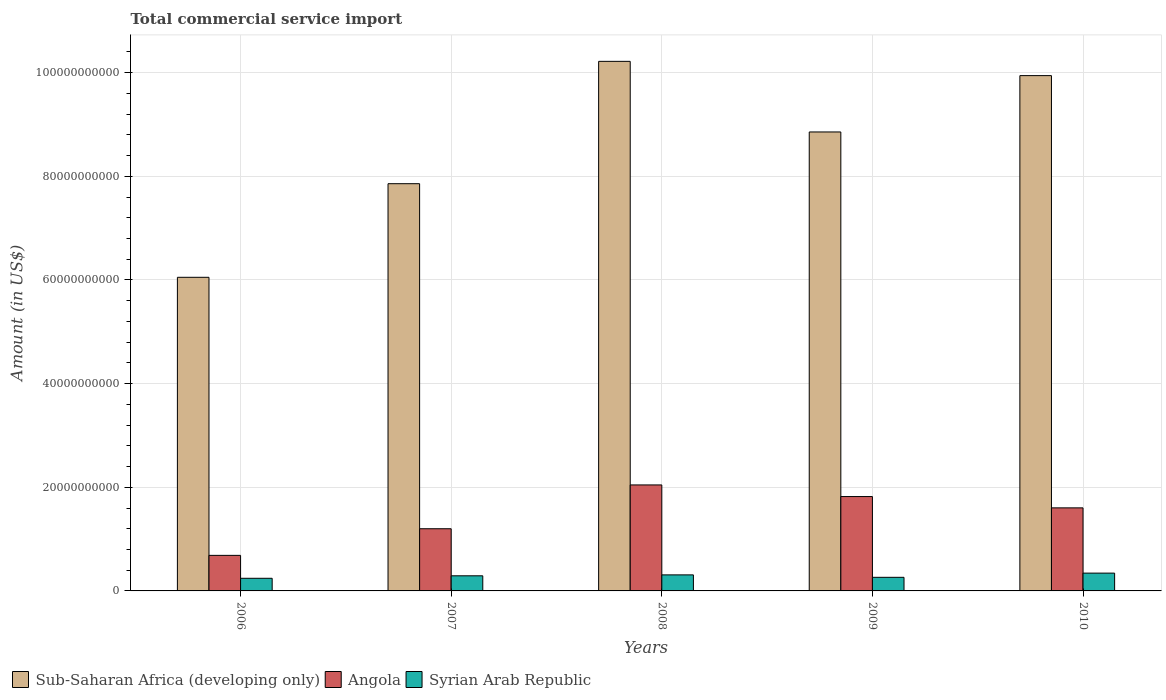How many different coloured bars are there?
Give a very brief answer. 3. Are the number of bars per tick equal to the number of legend labels?
Provide a succinct answer. Yes. Are the number of bars on each tick of the X-axis equal?
Give a very brief answer. Yes. How many bars are there on the 2nd tick from the left?
Your answer should be compact. 3. What is the label of the 3rd group of bars from the left?
Provide a short and direct response. 2008. What is the total commercial service import in Angola in 2007?
Give a very brief answer. 1.20e+1. Across all years, what is the maximum total commercial service import in Syrian Arab Republic?
Keep it short and to the point. 3.44e+09. Across all years, what is the minimum total commercial service import in Angola?
Offer a very short reply. 6.86e+09. What is the total total commercial service import in Angola in the graph?
Provide a short and direct response. 7.35e+1. What is the difference between the total commercial service import in Syrian Arab Republic in 2008 and that in 2010?
Provide a succinct answer. -3.41e+08. What is the difference between the total commercial service import in Syrian Arab Republic in 2009 and the total commercial service import in Angola in 2006?
Your response must be concise. -4.24e+09. What is the average total commercial service import in Angola per year?
Make the answer very short. 1.47e+1. In the year 2010, what is the difference between the total commercial service import in Sub-Saharan Africa (developing only) and total commercial service import in Syrian Arab Republic?
Your answer should be compact. 9.60e+1. In how many years, is the total commercial service import in Sub-Saharan Africa (developing only) greater than 96000000000 US$?
Offer a very short reply. 2. What is the ratio of the total commercial service import in Syrian Arab Republic in 2006 to that in 2007?
Keep it short and to the point. 0.84. Is the total commercial service import in Angola in 2006 less than that in 2008?
Give a very brief answer. Yes. What is the difference between the highest and the second highest total commercial service import in Syrian Arab Republic?
Give a very brief answer. 3.41e+08. What is the difference between the highest and the lowest total commercial service import in Sub-Saharan Africa (developing only)?
Your response must be concise. 4.17e+1. Is the sum of the total commercial service import in Sub-Saharan Africa (developing only) in 2006 and 2009 greater than the maximum total commercial service import in Syrian Arab Republic across all years?
Provide a short and direct response. Yes. What does the 2nd bar from the left in 2007 represents?
Your answer should be very brief. Angola. What does the 2nd bar from the right in 2010 represents?
Ensure brevity in your answer.  Angola. How many bars are there?
Provide a short and direct response. 15. What is the difference between two consecutive major ticks on the Y-axis?
Offer a terse response. 2.00e+1. Are the values on the major ticks of Y-axis written in scientific E-notation?
Provide a short and direct response. No. Does the graph contain any zero values?
Your answer should be very brief. No. Does the graph contain grids?
Give a very brief answer. Yes. Where does the legend appear in the graph?
Provide a succinct answer. Bottom left. What is the title of the graph?
Offer a terse response. Total commercial service import. What is the label or title of the X-axis?
Your answer should be very brief. Years. What is the label or title of the Y-axis?
Your answer should be very brief. Amount (in US$). What is the Amount (in US$) in Sub-Saharan Africa (developing only) in 2006?
Give a very brief answer. 6.05e+1. What is the Amount (in US$) of Angola in 2006?
Your answer should be compact. 6.86e+09. What is the Amount (in US$) in Syrian Arab Republic in 2006?
Offer a terse response. 2.44e+09. What is the Amount (in US$) of Sub-Saharan Africa (developing only) in 2007?
Provide a short and direct response. 7.86e+1. What is the Amount (in US$) in Angola in 2007?
Ensure brevity in your answer.  1.20e+1. What is the Amount (in US$) in Syrian Arab Republic in 2007?
Your response must be concise. 2.92e+09. What is the Amount (in US$) in Sub-Saharan Africa (developing only) in 2008?
Make the answer very short. 1.02e+11. What is the Amount (in US$) of Angola in 2008?
Provide a short and direct response. 2.05e+1. What is the Amount (in US$) of Syrian Arab Republic in 2008?
Ensure brevity in your answer.  3.10e+09. What is the Amount (in US$) of Sub-Saharan Africa (developing only) in 2009?
Provide a short and direct response. 8.86e+1. What is the Amount (in US$) in Angola in 2009?
Offer a terse response. 1.82e+1. What is the Amount (in US$) of Syrian Arab Republic in 2009?
Give a very brief answer. 2.62e+09. What is the Amount (in US$) of Sub-Saharan Africa (developing only) in 2010?
Provide a short and direct response. 9.94e+1. What is the Amount (in US$) of Angola in 2010?
Give a very brief answer. 1.60e+1. What is the Amount (in US$) in Syrian Arab Republic in 2010?
Offer a very short reply. 3.44e+09. Across all years, what is the maximum Amount (in US$) of Sub-Saharan Africa (developing only)?
Provide a short and direct response. 1.02e+11. Across all years, what is the maximum Amount (in US$) in Angola?
Ensure brevity in your answer.  2.05e+1. Across all years, what is the maximum Amount (in US$) of Syrian Arab Republic?
Provide a succinct answer. 3.44e+09. Across all years, what is the minimum Amount (in US$) of Sub-Saharan Africa (developing only)?
Keep it short and to the point. 6.05e+1. Across all years, what is the minimum Amount (in US$) of Angola?
Your answer should be compact. 6.86e+09. Across all years, what is the minimum Amount (in US$) of Syrian Arab Republic?
Offer a terse response. 2.44e+09. What is the total Amount (in US$) of Sub-Saharan Africa (developing only) in the graph?
Make the answer very short. 4.29e+11. What is the total Amount (in US$) in Angola in the graph?
Ensure brevity in your answer.  7.35e+1. What is the total Amount (in US$) of Syrian Arab Republic in the graph?
Make the answer very short. 1.45e+1. What is the difference between the Amount (in US$) of Sub-Saharan Africa (developing only) in 2006 and that in 2007?
Give a very brief answer. -1.81e+1. What is the difference between the Amount (in US$) in Angola in 2006 and that in 2007?
Provide a short and direct response. -5.14e+09. What is the difference between the Amount (in US$) of Syrian Arab Republic in 2006 and that in 2007?
Offer a terse response. -4.80e+08. What is the difference between the Amount (in US$) of Sub-Saharan Africa (developing only) in 2006 and that in 2008?
Provide a short and direct response. -4.17e+1. What is the difference between the Amount (in US$) of Angola in 2006 and that in 2008?
Your answer should be very brief. -1.36e+1. What is the difference between the Amount (in US$) in Syrian Arab Republic in 2006 and that in 2008?
Make the answer very short. -6.59e+08. What is the difference between the Amount (in US$) of Sub-Saharan Africa (developing only) in 2006 and that in 2009?
Your answer should be very brief. -2.80e+1. What is the difference between the Amount (in US$) of Angola in 2006 and that in 2009?
Give a very brief answer. -1.14e+1. What is the difference between the Amount (in US$) in Syrian Arab Republic in 2006 and that in 2009?
Offer a very short reply. -1.86e+08. What is the difference between the Amount (in US$) of Sub-Saharan Africa (developing only) in 2006 and that in 2010?
Offer a very short reply. -3.89e+1. What is the difference between the Amount (in US$) of Angola in 2006 and that in 2010?
Your response must be concise. -9.17e+09. What is the difference between the Amount (in US$) of Syrian Arab Republic in 2006 and that in 2010?
Provide a succinct answer. -1.00e+09. What is the difference between the Amount (in US$) in Sub-Saharan Africa (developing only) in 2007 and that in 2008?
Make the answer very short. -2.36e+1. What is the difference between the Amount (in US$) in Angola in 2007 and that in 2008?
Your answer should be compact. -8.45e+09. What is the difference between the Amount (in US$) of Syrian Arab Republic in 2007 and that in 2008?
Your answer should be compact. -1.80e+08. What is the difference between the Amount (in US$) in Sub-Saharan Africa (developing only) in 2007 and that in 2009?
Your response must be concise. -9.98e+09. What is the difference between the Amount (in US$) of Angola in 2007 and that in 2009?
Provide a succinct answer. -6.21e+09. What is the difference between the Amount (in US$) of Syrian Arab Republic in 2007 and that in 2009?
Give a very brief answer. 2.93e+08. What is the difference between the Amount (in US$) of Sub-Saharan Africa (developing only) in 2007 and that in 2010?
Keep it short and to the point. -2.09e+1. What is the difference between the Amount (in US$) of Angola in 2007 and that in 2010?
Offer a very short reply. -4.03e+09. What is the difference between the Amount (in US$) in Syrian Arab Republic in 2007 and that in 2010?
Your response must be concise. -5.20e+08. What is the difference between the Amount (in US$) of Sub-Saharan Africa (developing only) in 2008 and that in 2009?
Offer a very short reply. 1.36e+1. What is the difference between the Amount (in US$) in Angola in 2008 and that in 2009?
Your answer should be compact. 2.24e+09. What is the difference between the Amount (in US$) of Syrian Arab Republic in 2008 and that in 2009?
Give a very brief answer. 4.73e+08. What is the difference between the Amount (in US$) of Sub-Saharan Africa (developing only) in 2008 and that in 2010?
Your response must be concise. 2.75e+09. What is the difference between the Amount (in US$) of Angola in 2008 and that in 2010?
Provide a short and direct response. 4.42e+09. What is the difference between the Amount (in US$) in Syrian Arab Republic in 2008 and that in 2010?
Your response must be concise. -3.41e+08. What is the difference between the Amount (in US$) of Sub-Saharan Africa (developing only) in 2009 and that in 2010?
Give a very brief answer. -1.09e+1. What is the difference between the Amount (in US$) of Angola in 2009 and that in 2010?
Your response must be concise. 2.18e+09. What is the difference between the Amount (in US$) in Syrian Arab Republic in 2009 and that in 2010?
Your response must be concise. -8.14e+08. What is the difference between the Amount (in US$) of Sub-Saharan Africa (developing only) in 2006 and the Amount (in US$) of Angola in 2007?
Ensure brevity in your answer.  4.85e+1. What is the difference between the Amount (in US$) of Sub-Saharan Africa (developing only) in 2006 and the Amount (in US$) of Syrian Arab Republic in 2007?
Offer a very short reply. 5.76e+1. What is the difference between the Amount (in US$) of Angola in 2006 and the Amount (in US$) of Syrian Arab Republic in 2007?
Your response must be concise. 3.94e+09. What is the difference between the Amount (in US$) in Sub-Saharan Africa (developing only) in 2006 and the Amount (in US$) in Angola in 2008?
Offer a terse response. 4.01e+1. What is the difference between the Amount (in US$) in Sub-Saharan Africa (developing only) in 2006 and the Amount (in US$) in Syrian Arab Republic in 2008?
Make the answer very short. 5.74e+1. What is the difference between the Amount (in US$) in Angola in 2006 and the Amount (in US$) in Syrian Arab Republic in 2008?
Keep it short and to the point. 3.76e+09. What is the difference between the Amount (in US$) of Sub-Saharan Africa (developing only) in 2006 and the Amount (in US$) of Angola in 2009?
Give a very brief answer. 4.23e+1. What is the difference between the Amount (in US$) of Sub-Saharan Africa (developing only) in 2006 and the Amount (in US$) of Syrian Arab Republic in 2009?
Offer a very short reply. 5.79e+1. What is the difference between the Amount (in US$) of Angola in 2006 and the Amount (in US$) of Syrian Arab Republic in 2009?
Ensure brevity in your answer.  4.24e+09. What is the difference between the Amount (in US$) in Sub-Saharan Africa (developing only) in 2006 and the Amount (in US$) in Angola in 2010?
Ensure brevity in your answer.  4.45e+1. What is the difference between the Amount (in US$) of Sub-Saharan Africa (developing only) in 2006 and the Amount (in US$) of Syrian Arab Republic in 2010?
Keep it short and to the point. 5.71e+1. What is the difference between the Amount (in US$) of Angola in 2006 and the Amount (in US$) of Syrian Arab Republic in 2010?
Make the answer very short. 3.42e+09. What is the difference between the Amount (in US$) in Sub-Saharan Africa (developing only) in 2007 and the Amount (in US$) in Angola in 2008?
Provide a succinct answer. 5.81e+1. What is the difference between the Amount (in US$) of Sub-Saharan Africa (developing only) in 2007 and the Amount (in US$) of Syrian Arab Republic in 2008?
Give a very brief answer. 7.55e+1. What is the difference between the Amount (in US$) in Angola in 2007 and the Amount (in US$) in Syrian Arab Republic in 2008?
Offer a very short reply. 8.90e+09. What is the difference between the Amount (in US$) of Sub-Saharan Africa (developing only) in 2007 and the Amount (in US$) of Angola in 2009?
Offer a very short reply. 6.04e+1. What is the difference between the Amount (in US$) of Sub-Saharan Africa (developing only) in 2007 and the Amount (in US$) of Syrian Arab Republic in 2009?
Make the answer very short. 7.60e+1. What is the difference between the Amount (in US$) of Angola in 2007 and the Amount (in US$) of Syrian Arab Republic in 2009?
Offer a terse response. 9.37e+09. What is the difference between the Amount (in US$) in Sub-Saharan Africa (developing only) in 2007 and the Amount (in US$) in Angola in 2010?
Your answer should be very brief. 6.26e+1. What is the difference between the Amount (in US$) in Sub-Saharan Africa (developing only) in 2007 and the Amount (in US$) in Syrian Arab Republic in 2010?
Offer a terse response. 7.51e+1. What is the difference between the Amount (in US$) of Angola in 2007 and the Amount (in US$) of Syrian Arab Republic in 2010?
Give a very brief answer. 8.56e+09. What is the difference between the Amount (in US$) of Sub-Saharan Africa (developing only) in 2008 and the Amount (in US$) of Angola in 2009?
Offer a terse response. 8.40e+1. What is the difference between the Amount (in US$) of Sub-Saharan Africa (developing only) in 2008 and the Amount (in US$) of Syrian Arab Republic in 2009?
Provide a succinct answer. 9.96e+1. What is the difference between the Amount (in US$) in Angola in 2008 and the Amount (in US$) in Syrian Arab Republic in 2009?
Keep it short and to the point. 1.78e+1. What is the difference between the Amount (in US$) in Sub-Saharan Africa (developing only) in 2008 and the Amount (in US$) in Angola in 2010?
Give a very brief answer. 8.62e+1. What is the difference between the Amount (in US$) in Sub-Saharan Africa (developing only) in 2008 and the Amount (in US$) in Syrian Arab Republic in 2010?
Provide a short and direct response. 9.88e+1. What is the difference between the Amount (in US$) of Angola in 2008 and the Amount (in US$) of Syrian Arab Republic in 2010?
Your response must be concise. 1.70e+1. What is the difference between the Amount (in US$) in Sub-Saharan Africa (developing only) in 2009 and the Amount (in US$) in Angola in 2010?
Offer a very short reply. 7.25e+1. What is the difference between the Amount (in US$) in Sub-Saharan Africa (developing only) in 2009 and the Amount (in US$) in Syrian Arab Republic in 2010?
Your response must be concise. 8.51e+1. What is the difference between the Amount (in US$) of Angola in 2009 and the Amount (in US$) of Syrian Arab Republic in 2010?
Keep it short and to the point. 1.48e+1. What is the average Amount (in US$) in Sub-Saharan Africa (developing only) per year?
Provide a short and direct response. 8.59e+1. What is the average Amount (in US$) of Angola per year?
Your answer should be very brief. 1.47e+1. What is the average Amount (in US$) of Syrian Arab Republic per year?
Your answer should be very brief. 2.90e+09. In the year 2006, what is the difference between the Amount (in US$) of Sub-Saharan Africa (developing only) and Amount (in US$) of Angola?
Offer a very short reply. 5.37e+1. In the year 2006, what is the difference between the Amount (in US$) in Sub-Saharan Africa (developing only) and Amount (in US$) in Syrian Arab Republic?
Ensure brevity in your answer.  5.81e+1. In the year 2006, what is the difference between the Amount (in US$) in Angola and Amount (in US$) in Syrian Arab Republic?
Provide a succinct answer. 4.42e+09. In the year 2007, what is the difference between the Amount (in US$) in Sub-Saharan Africa (developing only) and Amount (in US$) in Angola?
Ensure brevity in your answer.  6.66e+1. In the year 2007, what is the difference between the Amount (in US$) in Sub-Saharan Africa (developing only) and Amount (in US$) in Syrian Arab Republic?
Offer a terse response. 7.57e+1. In the year 2007, what is the difference between the Amount (in US$) in Angola and Amount (in US$) in Syrian Arab Republic?
Provide a short and direct response. 9.08e+09. In the year 2008, what is the difference between the Amount (in US$) in Sub-Saharan Africa (developing only) and Amount (in US$) in Angola?
Ensure brevity in your answer.  8.17e+1. In the year 2008, what is the difference between the Amount (in US$) of Sub-Saharan Africa (developing only) and Amount (in US$) of Syrian Arab Republic?
Offer a terse response. 9.91e+1. In the year 2008, what is the difference between the Amount (in US$) of Angola and Amount (in US$) of Syrian Arab Republic?
Make the answer very short. 1.74e+1. In the year 2009, what is the difference between the Amount (in US$) of Sub-Saharan Africa (developing only) and Amount (in US$) of Angola?
Your answer should be compact. 7.04e+1. In the year 2009, what is the difference between the Amount (in US$) in Sub-Saharan Africa (developing only) and Amount (in US$) in Syrian Arab Republic?
Your response must be concise. 8.59e+1. In the year 2009, what is the difference between the Amount (in US$) of Angola and Amount (in US$) of Syrian Arab Republic?
Your answer should be very brief. 1.56e+1. In the year 2010, what is the difference between the Amount (in US$) in Sub-Saharan Africa (developing only) and Amount (in US$) in Angola?
Make the answer very short. 8.34e+1. In the year 2010, what is the difference between the Amount (in US$) in Sub-Saharan Africa (developing only) and Amount (in US$) in Syrian Arab Republic?
Give a very brief answer. 9.60e+1. In the year 2010, what is the difference between the Amount (in US$) of Angola and Amount (in US$) of Syrian Arab Republic?
Give a very brief answer. 1.26e+1. What is the ratio of the Amount (in US$) in Sub-Saharan Africa (developing only) in 2006 to that in 2007?
Offer a very short reply. 0.77. What is the ratio of the Amount (in US$) in Angola in 2006 to that in 2007?
Your answer should be compact. 0.57. What is the ratio of the Amount (in US$) in Syrian Arab Republic in 2006 to that in 2007?
Keep it short and to the point. 0.84. What is the ratio of the Amount (in US$) of Sub-Saharan Africa (developing only) in 2006 to that in 2008?
Offer a terse response. 0.59. What is the ratio of the Amount (in US$) in Angola in 2006 to that in 2008?
Your answer should be very brief. 0.34. What is the ratio of the Amount (in US$) of Syrian Arab Republic in 2006 to that in 2008?
Your response must be concise. 0.79. What is the ratio of the Amount (in US$) of Sub-Saharan Africa (developing only) in 2006 to that in 2009?
Offer a very short reply. 0.68. What is the ratio of the Amount (in US$) of Angola in 2006 to that in 2009?
Ensure brevity in your answer.  0.38. What is the ratio of the Amount (in US$) in Syrian Arab Republic in 2006 to that in 2009?
Your response must be concise. 0.93. What is the ratio of the Amount (in US$) of Sub-Saharan Africa (developing only) in 2006 to that in 2010?
Offer a terse response. 0.61. What is the ratio of the Amount (in US$) in Angola in 2006 to that in 2010?
Provide a succinct answer. 0.43. What is the ratio of the Amount (in US$) in Syrian Arab Republic in 2006 to that in 2010?
Your answer should be compact. 0.71. What is the ratio of the Amount (in US$) of Sub-Saharan Africa (developing only) in 2007 to that in 2008?
Ensure brevity in your answer.  0.77. What is the ratio of the Amount (in US$) in Angola in 2007 to that in 2008?
Give a very brief answer. 0.59. What is the ratio of the Amount (in US$) of Syrian Arab Republic in 2007 to that in 2008?
Provide a succinct answer. 0.94. What is the ratio of the Amount (in US$) of Sub-Saharan Africa (developing only) in 2007 to that in 2009?
Provide a succinct answer. 0.89. What is the ratio of the Amount (in US$) of Angola in 2007 to that in 2009?
Offer a terse response. 0.66. What is the ratio of the Amount (in US$) in Syrian Arab Republic in 2007 to that in 2009?
Provide a short and direct response. 1.11. What is the ratio of the Amount (in US$) in Sub-Saharan Africa (developing only) in 2007 to that in 2010?
Your response must be concise. 0.79. What is the ratio of the Amount (in US$) in Angola in 2007 to that in 2010?
Ensure brevity in your answer.  0.75. What is the ratio of the Amount (in US$) in Syrian Arab Republic in 2007 to that in 2010?
Give a very brief answer. 0.85. What is the ratio of the Amount (in US$) in Sub-Saharan Africa (developing only) in 2008 to that in 2009?
Your response must be concise. 1.15. What is the ratio of the Amount (in US$) of Angola in 2008 to that in 2009?
Your answer should be very brief. 1.12. What is the ratio of the Amount (in US$) of Syrian Arab Republic in 2008 to that in 2009?
Make the answer very short. 1.18. What is the ratio of the Amount (in US$) of Sub-Saharan Africa (developing only) in 2008 to that in 2010?
Offer a very short reply. 1.03. What is the ratio of the Amount (in US$) of Angola in 2008 to that in 2010?
Your answer should be very brief. 1.28. What is the ratio of the Amount (in US$) in Syrian Arab Republic in 2008 to that in 2010?
Provide a succinct answer. 0.9. What is the ratio of the Amount (in US$) of Sub-Saharan Africa (developing only) in 2009 to that in 2010?
Ensure brevity in your answer.  0.89. What is the ratio of the Amount (in US$) of Angola in 2009 to that in 2010?
Offer a very short reply. 1.14. What is the ratio of the Amount (in US$) of Syrian Arab Republic in 2009 to that in 2010?
Provide a succinct answer. 0.76. What is the difference between the highest and the second highest Amount (in US$) in Sub-Saharan Africa (developing only)?
Offer a very short reply. 2.75e+09. What is the difference between the highest and the second highest Amount (in US$) of Angola?
Provide a succinct answer. 2.24e+09. What is the difference between the highest and the second highest Amount (in US$) in Syrian Arab Republic?
Provide a succinct answer. 3.41e+08. What is the difference between the highest and the lowest Amount (in US$) in Sub-Saharan Africa (developing only)?
Ensure brevity in your answer.  4.17e+1. What is the difference between the highest and the lowest Amount (in US$) in Angola?
Your answer should be compact. 1.36e+1. What is the difference between the highest and the lowest Amount (in US$) of Syrian Arab Republic?
Provide a short and direct response. 1.00e+09. 